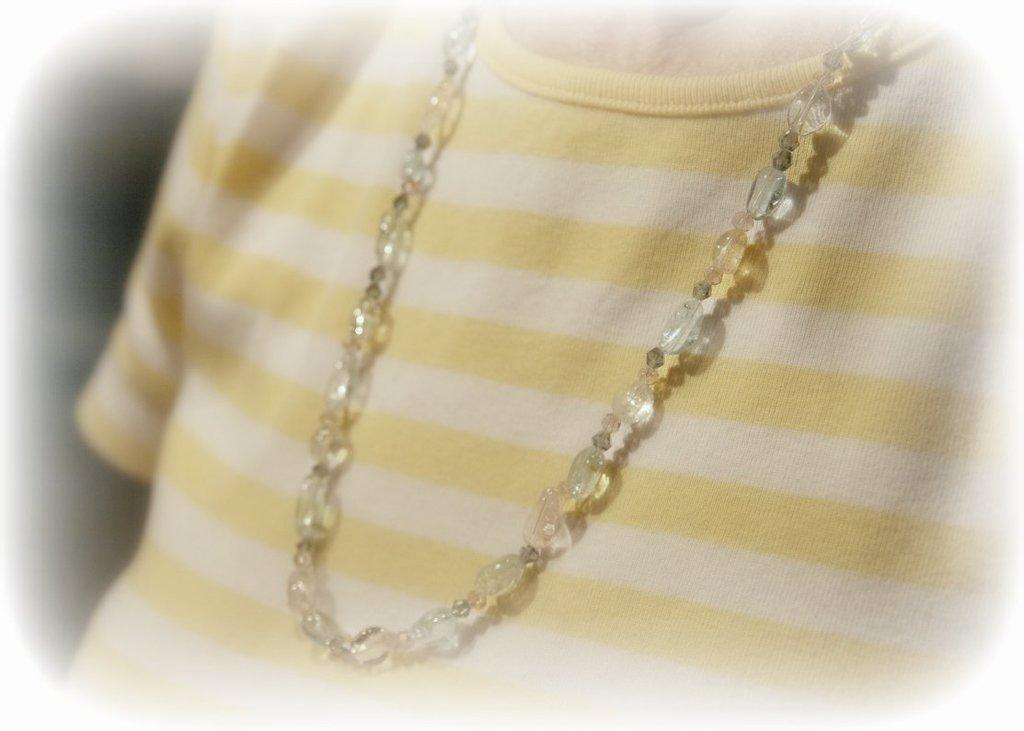Could you give a brief overview of what you see in this image? This looks like an edited image. I can see a person with T-shirt and beads necklace. 